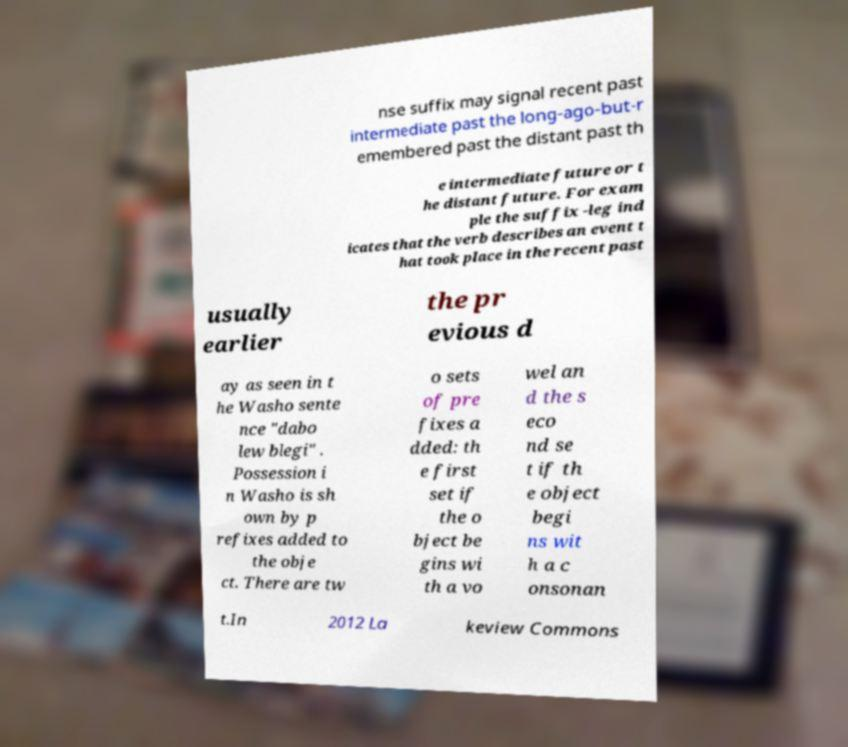What messages or text are displayed in this image? I need them in a readable, typed format. nse suffix may signal recent past intermediate past the long-ago-but-r emembered past the distant past th e intermediate future or t he distant future. For exam ple the suffix -leg ind icates that the verb describes an event t hat took place in the recent past usually earlier the pr evious d ay as seen in t he Washo sente nce "dabo lew blegi" . Possession i n Washo is sh own by p refixes added to the obje ct. There are tw o sets of pre fixes a dded: th e first set if the o bject be gins wi th a vo wel an d the s eco nd se t if th e object begi ns wit h a c onsonan t.In 2012 La keview Commons 